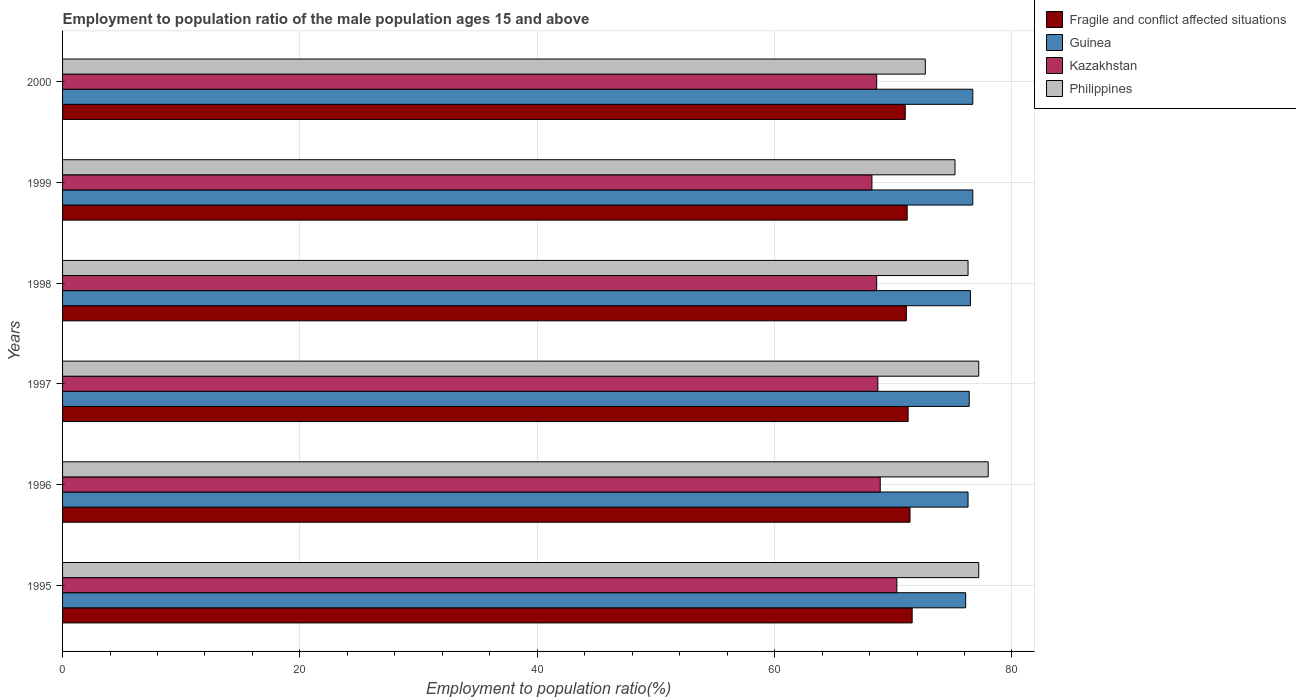How many different coloured bars are there?
Offer a terse response. 4. How many groups of bars are there?
Your response must be concise. 6. Are the number of bars on each tick of the Y-axis equal?
Keep it short and to the point. Yes. How many bars are there on the 5th tick from the bottom?
Provide a short and direct response. 4. What is the employment to population ratio in Guinea in 1997?
Provide a short and direct response. 76.4. Across all years, what is the maximum employment to population ratio in Kazakhstan?
Offer a terse response. 70.3. Across all years, what is the minimum employment to population ratio in Philippines?
Make the answer very short. 72.7. In which year was the employment to population ratio in Philippines maximum?
Your answer should be very brief. 1996. In which year was the employment to population ratio in Guinea minimum?
Offer a very short reply. 1995. What is the total employment to population ratio in Guinea in the graph?
Your answer should be compact. 458.7. What is the difference between the employment to population ratio in Fragile and conflict affected situations in 1998 and that in 2000?
Give a very brief answer. 0.09. What is the difference between the employment to population ratio in Kazakhstan in 1995 and the employment to population ratio in Guinea in 1997?
Your answer should be compact. -6.1. What is the average employment to population ratio in Kazakhstan per year?
Provide a short and direct response. 68.88. In the year 2000, what is the difference between the employment to population ratio in Kazakhstan and employment to population ratio in Fragile and conflict affected situations?
Give a very brief answer. -2.41. In how many years, is the employment to population ratio in Fragile and conflict affected situations greater than 4 %?
Offer a terse response. 6. What is the ratio of the employment to population ratio in Kazakhstan in 1997 to that in 1998?
Provide a short and direct response. 1. What is the difference between the highest and the second highest employment to population ratio in Kazakhstan?
Your answer should be compact. 1.4. What is the difference between the highest and the lowest employment to population ratio in Philippines?
Your answer should be very brief. 5.3. Is the sum of the employment to population ratio in Fragile and conflict affected situations in 1997 and 1998 greater than the maximum employment to population ratio in Guinea across all years?
Keep it short and to the point. Yes. What does the 3rd bar from the bottom in 2000 represents?
Ensure brevity in your answer.  Kazakhstan. Is it the case that in every year, the sum of the employment to population ratio in Guinea and employment to population ratio in Kazakhstan is greater than the employment to population ratio in Fragile and conflict affected situations?
Your response must be concise. Yes. How many years are there in the graph?
Provide a short and direct response. 6. What is the difference between two consecutive major ticks on the X-axis?
Ensure brevity in your answer.  20. Does the graph contain any zero values?
Your response must be concise. No. Does the graph contain grids?
Ensure brevity in your answer.  Yes. Where does the legend appear in the graph?
Offer a very short reply. Top right. How many legend labels are there?
Offer a very short reply. 4. What is the title of the graph?
Your response must be concise. Employment to population ratio of the male population ages 15 and above. What is the label or title of the X-axis?
Ensure brevity in your answer.  Employment to population ratio(%). What is the Employment to population ratio(%) of Fragile and conflict affected situations in 1995?
Offer a very short reply. 71.59. What is the Employment to population ratio(%) of Guinea in 1995?
Provide a succinct answer. 76.1. What is the Employment to population ratio(%) in Kazakhstan in 1995?
Your answer should be very brief. 70.3. What is the Employment to population ratio(%) in Philippines in 1995?
Ensure brevity in your answer.  77.2. What is the Employment to population ratio(%) of Fragile and conflict affected situations in 1996?
Make the answer very short. 71.41. What is the Employment to population ratio(%) in Guinea in 1996?
Offer a very short reply. 76.3. What is the Employment to population ratio(%) in Kazakhstan in 1996?
Make the answer very short. 68.9. What is the Employment to population ratio(%) in Fragile and conflict affected situations in 1997?
Your answer should be compact. 71.25. What is the Employment to population ratio(%) of Guinea in 1997?
Keep it short and to the point. 76.4. What is the Employment to population ratio(%) in Kazakhstan in 1997?
Make the answer very short. 68.7. What is the Employment to population ratio(%) in Philippines in 1997?
Provide a succinct answer. 77.2. What is the Employment to population ratio(%) of Fragile and conflict affected situations in 1998?
Your answer should be very brief. 71.1. What is the Employment to population ratio(%) in Guinea in 1998?
Ensure brevity in your answer.  76.5. What is the Employment to population ratio(%) of Kazakhstan in 1998?
Offer a terse response. 68.6. What is the Employment to population ratio(%) of Philippines in 1998?
Your answer should be very brief. 76.3. What is the Employment to population ratio(%) in Fragile and conflict affected situations in 1999?
Make the answer very short. 71.17. What is the Employment to population ratio(%) of Guinea in 1999?
Provide a succinct answer. 76.7. What is the Employment to population ratio(%) in Kazakhstan in 1999?
Give a very brief answer. 68.2. What is the Employment to population ratio(%) in Philippines in 1999?
Ensure brevity in your answer.  75.2. What is the Employment to population ratio(%) of Fragile and conflict affected situations in 2000?
Make the answer very short. 71.01. What is the Employment to population ratio(%) in Guinea in 2000?
Provide a short and direct response. 76.7. What is the Employment to population ratio(%) in Kazakhstan in 2000?
Ensure brevity in your answer.  68.6. What is the Employment to population ratio(%) in Philippines in 2000?
Offer a terse response. 72.7. Across all years, what is the maximum Employment to population ratio(%) in Fragile and conflict affected situations?
Offer a very short reply. 71.59. Across all years, what is the maximum Employment to population ratio(%) in Guinea?
Keep it short and to the point. 76.7. Across all years, what is the maximum Employment to population ratio(%) in Kazakhstan?
Keep it short and to the point. 70.3. Across all years, what is the maximum Employment to population ratio(%) in Philippines?
Offer a terse response. 78. Across all years, what is the minimum Employment to population ratio(%) of Fragile and conflict affected situations?
Provide a short and direct response. 71.01. Across all years, what is the minimum Employment to population ratio(%) in Guinea?
Keep it short and to the point. 76.1. Across all years, what is the minimum Employment to population ratio(%) in Kazakhstan?
Your answer should be compact. 68.2. Across all years, what is the minimum Employment to population ratio(%) of Philippines?
Provide a short and direct response. 72.7. What is the total Employment to population ratio(%) in Fragile and conflict affected situations in the graph?
Provide a short and direct response. 427.53. What is the total Employment to population ratio(%) of Guinea in the graph?
Offer a terse response. 458.7. What is the total Employment to population ratio(%) of Kazakhstan in the graph?
Make the answer very short. 413.3. What is the total Employment to population ratio(%) in Philippines in the graph?
Offer a terse response. 456.6. What is the difference between the Employment to population ratio(%) of Fragile and conflict affected situations in 1995 and that in 1996?
Give a very brief answer. 0.18. What is the difference between the Employment to population ratio(%) of Philippines in 1995 and that in 1996?
Provide a succinct answer. -0.8. What is the difference between the Employment to population ratio(%) in Fragile and conflict affected situations in 1995 and that in 1997?
Provide a short and direct response. 0.34. What is the difference between the Employment to population ratio(%) of Fragile and conflict affected situations in 1995 and that in 1998?
Give a very brief answer. 0.49. What is the difference between the Employment to population ratio(%) in Kazakhstan in 1995 and that in 1998?
Offer a terse response. 1.7. What is the difference between the Employment to population ratio(%) in Fragile and conflict affected situations in 1995 and that in 1999?
Provide a succinct answer. 0.42. What is the difference between the Employment to population ratio(%) in Philippines in 1995 and that in 1999?
Offer a terse response. 2. What is the difference between the Employment to population ratio(%) in Fragile and conflict affected situations in 1995 and that in 2000?
Provide a succinct answer. 0.58. What is the difference between the Employment to population ratio(%) in Kazakhstan in 1995 and that in 2000?
Your answer should be compact. 1.7. What is the difference between the Employment to population ratio(%) in Fragile and conflict affected situations in 1996 and that in 1997?
Provide a short and direct response. 0.16. What is the difference between the Employment to population ratio(%) of Guinea in 1996 and that in 1997?
Provide a short and direct response. -0.1. What is the difference between the Employment to population ratio(%) in Philippines in 1996 and that in 1997?
Your answer should be compact. 0.8. What is the difference between the Employment to population ratio(%) in Fragile and conflict affected situations in 1996 and that in 1998?
Provide a short and direct response. 0.31. What is the difference between the Employment to population ratio(%) in Fragile and conflict affected situations in 1996 and that in 1999?
Give a very brief answer. 0.24. What is the difference between the Employment to population ratio(%) of Philippines in 1996 and that in 1999?
Your response must be concise. 2.8. What is the difference between the Employment to population ratio(%) in Fragile and conflict affected situations in 1996 and that in 2000?
Your answer should be very brief. 0.4. What is the difference between the Employment to population ratio(%) in Kazakhstan in 1996 and that in 2000?
Your answer should be very brief. 0.3. What is the difference between the Employment to population ratio(%) of Fragile and conflict affected situations in 1997 and that in 1998?
Offer a very short reply. 0.15. What is the difference between the Employment to population ratio(%) of Kazakhstan in 1997 and that in 1998?
Keep it short and to the point. 0.1. What is the difference between the Employment to population ratio(%) in Philippines in 1997 and that in 1998?
Give a very brief answer. 0.9. What is the difference between the Employment to population ratio(%) in Fragile and conflict affected situations in 1997 and that in 1999?
Your response must be concise. 0.08. What is the difference between the Employment to population ratio(%) of Guinea in 1997 and that in 1999?
Keep it short and to the point. -0.3. What is the difference between the Employment to population ratio(%) of Philippines in 1997 and that in 1999?
Keep it short and to the point. 2. What is the difference between the Employment to population ratio(%) in Fragile and conflict affected situations in 1997 and that in 2000?
Your answer should be very brief. 0.24. What is the difference between the Employment to population ratio(%) in Philippines in 1997 and that in 2000?
Make the answer very short. 4.5. What is the difference between the Employment to population ratio(%) in Fragile and conflict affected situations in 1998 and that in 1999?
Offer a terse response. -0.07. What is the difference between the Employment to population ratio(%) in Guinea in 1998 and that in 1999?
Provide a succinct answer. -0.2. What is the difference between the Employment to population ratio(%) of Kazakhstan in 1998 and that in 1999?
Your answer should be compact. 0.4. What is the difference between the Employment to population ratio(%) in Philippines in 1998 and that in 1999?
Your response must be concise. 1.1. What is the difference between the Employment to population ratio(%) in Fragile and conflict affected situations in 1998 and that in 2000?
Ensure brevity in your answer.  0.09. What is the difference between the Employment to population ratio(%) in Philippines in 1998 and that in 2000?
Your answer should be very brief. 3.6. What is the difference between the Employment to population ratio(%) in Fragile and conflict affected situations in 1999 and that in 2000?
Your answer should be compact. 0.16. What is the difference between the Employment to population ratio(%) in Guinea in 1999 and that in 2000?
Your answer should be very brief. 0. What is the difference between the Employment to population ratio(%) in Fragile and conflict affected situations in 1995 and the Employment to population ratio(%) in Guinea in 1996?
Your answer should be very brief. -4.71. What is the difference between the Employment to population ratio(%) in Fragile and conflict affected situations in 1995 and the Employment to population ratio(%) in Kazakhstan in 1996?
Keep it short and to the point. 2.69. What is the difference between the Employment to population ratio(%) of Fragile and conflict affected situations in 1995 and the Employment to population ratio(%) of Philippines in 1996?
Keep it short and to the point. -6.41. What is the difference between the Employment to population ratio(%) in Kazakhstan in 1995 and the Employment to population ratio(%) in Philippines in 1996?
Your response must be concise. -7.7. What is the difference between the Employment to population ratio(%) in Fragile and conflict affected situations in 1995 and the Employment to population ratio(%) in Guinea in 1997?
Your response must be concise. -4.81. What is the difference between the Employment to population ratio(%) in Fragile and conflict affected situations in 1995 and the Employment to population ratio(%) in Kazakhstan in 1997?
Keep it short and to the point. 2.89. What is the difference between the Employment to population ratio(%) of Fragile and conflict affected situations in 1995 and the Employment to population ratio(%) of Philippines in 1997?
Make the answer very short. -5.61. What is the difference between the Employment to population ratio(%) in Guinea in 1995 and the Employment to population ratio(%) in Kazakhstan in 1997?
Make the answer very short. 7.4. What is the difference between the Employment to population ratio(%) of Guinea in 1995 and the Employment to population ratio(%) of Philippines in 1997?
Your response must be concise. -1.1. What is the difference between the Employment to population ratio(%) in Kazakhstan in 1995 and the Employment to population ratio(%) in Philippines in 1997?
Provide a succinct answer. -6.9. What is the difference between the Employment to population ratio(%) in Fragile and conflict affected situations in 1995 and the Employment to population ratio(%) in Guinea in 1998?
Your answer should be compact. -4.91. What is the difference between the Employment to population ratio(%) of Fragile and conflict affected situations in 1995 and the Employment to population ratio(%) of Kazakhstan in 1998?
Your answer should be very brief. 2.99. What is the difference between the Employment to population ratio(%) in Fragile and conflict affected situations in 1995 and the Employment to population ratio(%) in Philippines in 1998?
Provide a succinct answer. -4.71. What is the difference between the Employment to population ratio(%) in Guinea in 1995 and the Employment to population ratio(%) in Philippines in 1998?
Your answer should be very brief. -0.2. What is the difference between the Employment to population ratio(%) of Kazakhstan in 1995 and the Employment to population ratio(%) of Philippines in 1998?
Keep it short and to the point. -6. What is the difference between the Employment to population ratio(%) of Fragile and conflict affected situations in 1995 and the Employment to population ratio(%) of Guinea in 1999?
Offer a very short reply. -5.11. What is the difference between the Employment to population ratio(%) in Fragile and conflict affected situations in 1995 and the Employment to population ratio(%) in Kazakhstan in 1999?
Provide a short and direct response. 3.39. What is the difference between the Employment to population ratio(%) of Fragile and conflict affected situations in 1995 and the Employment to population ratio(%) of Philippines in 1999?
Your answer should be very brief. -3.61. What is the difference between the Employment to population ratio(%) of Guinea in 1995 and the Employment to population ratio(%) of Philippines in 1999?
Provide a succinct answer. 0.9. What is the difference between the Employment to population ratio(%) of Kazakhstan in 1995 and the Employment to population ratio(%) of Philippines in 1999?
Offer a very short reply. -4.9. What is the difference between the Employment to population ratio(%) in Fragile and conflict affected situations in 1995 and the Employment to population ratio(%) in Guinea in 2000?
Your answer should be compact. -5.11. What is the difference between the Employment to population ratio(%) in Fragile and conflict affected situations in 1995 and the Employment to population ratio(%) in Kazakhstan in 2000?
Your answer should be very brief. 2.99. What is the difference between the Employment to population ratio(%) in Fragile and conflict affected situations in 1995 and the Employment to population ratio(%) in Philippines in 2000?
Give a very brief answer. -1.11. What is the difference between the Employment to population ratio(%) of Guinea in 1995 and the Employment to population ratio(%) of Philippines in 2000?
Provide a short and direct response. 3.4. What is the difference between the Employment to population ratio(%) in Kazakhstan in 1995 and the Employment to population ratio(%) in Philippines in 2000?
Provide a succinct answer. -2.4. What is the difference between the Employment to population ratio(%) of Fragile and conflict affected situations in 1996 and the Employment to population ratio(%) of Guinea in 1997?
Give a very brief answer. -4.99. What is the difference between the Employment to population ratio(%) in Fragile and conflict affected situations in 1996 and the Employment to population ratio(%) in Kazakhstan in 1997?
Keep it short and to the point. 2.71. What is the difference between the Employment to population ratio(%) in Fragile and conflict affected situations in 1996 and the Employment to population ratio(%) in Philippines in 1997?
Your answer should be compact. -5.79. What is the difference between the Employment to population ratio(%) in Guinea in 1996 and the Employment to population ratio(%) in Kazakhstan in 1997?
Offer a very short reply. 7.6. What is the difference between the Employment to population ratio(%) of Kazakhstan in 1996 and the Employment to population ratio(%) of Philippines in 1997?
Offer a terse response. -8.3. What is the difference between the Employment to population ratio(%) in Fragile and conflict affected situations in 1996 and the Employment to population ratio(%) in Guinea in 1998?
Keep it short and to the point. -5.09. What is the difference between the Employment to population ratio(%) of Fragile and conflict affected situations in 1996 and the Employment to population ratio(%) of Kazakhstan in 1998?
Your answer should be compact. 2.81. What is the difference between the Employment to population ratio(%) in Fragile and conflict affected situations in 1996 and the Employment to population ratio(%) in Philippines in 1998?
Offer a terse response. -4.89. What is the difference between the Employment to population ratio(%) in Fragile and conflict affected situations in 1996 and the Employment to population ratio(%) in Guinea in 1999?
Provide a succinct answer. -5.29. What is the difference between the Employment to population ratio(%) in Fragile and conflict affected situations in 1996 and the Employment to population ratio(%) in Kazakhstan in 1999?
Offer a terse response. 3.21. What is the difference between the Employment to population ratio(%) in Fragile and conflict affected situations in 1996 and the Employment to population ratio(%) in Philippines in 1999?
Offer a terse response. -3.79. What is the difference between the Employment to population ratio(%) in Kazakhstan in 1996 and the Employment to population ratio(%) in Philippines in 1999?
Keep it short and to the point. -6.3. What is the difference between the Employment to population ratio(%) in Fragile and conflict affected situations in 1996 and the Employment to population ratio(%) in Guinea in 2000?
Give a very brief answer. -5.29. What is the difference between the Employment to population ratio(%) in Fragile and conflict affected situations in 1996 and the Employment to population ratio(%) in Kazakhstan in 2000?
Offer a very short reply. 2.81. What is the difference between the Employment to population ratio(%) of Fragile and conflict affected situations in 1996 and the Employment to population ratio(%) of Philippines in 2000?
Keep it short and to the point. -1.29. What is the difference between the Employment to population ratio(%) of Guinea in 1996 and the Employment to population ratio(%) of Philippines in 2000?
Your answer should be very brief. 3.6. What is the difference between the Employment to population ratio(%) in Kazakhstan in 1996 and the Employment to population ratio(%) in Philippines in 2000?
Make the answer very short. -3.8. What is the difference between the Employment to population ratio(%) in Fragile and conflict affected situations in 1997 and the Employment to population ratio(%) in Guinea in 1998?
Ensure brevity in your answer.  -5.25. What is the difference between the Employment to population ratio(%) of Fragile and conflict affected situations in 1997 and the Employment to population ratio(%) of Kazakhstan in 1998?
Your response must be concise. 2.65. What is the difference between the Employment to population ratio(%) of Fragile and conflict affected situations in 1997 and the Employment to population ratio(%) of Philippines in 1998?
Ensure brevity in your answer.  -5.05. What is the difference between the Employment to population ratio(%) of Guinea in 1997 and the Employment to population ratio(%) of Philippines in 1998?
Ensure brevity in your answer.  0.1. What is the difference between the Employment to population ratio(%) of Fragile and conflict affected situations in 1997 and the Employment to population ratio(%) of Guinea in 1999?
Keep it short and to the point. -5.45. What is the difference between the Employment to population ratio(%) of Fragile and conflict affected situations in 1997 and the Employment to population ratio(%) of Kazakhstan in 1999?
Make the answer very short. 3.05. What is the difference between the Employment to population ratio(%) in Fragile and conflict affected situations in 1997 and the Employment to population ratio(%) in Philippines in 1999?
Offer a terse response. -3.95. What is the difference between the Employment to population ratio(%) in Guinea in 1997 and the Employment to population ratio(%) in Kazakhstan in 1999?
Provide a succinct answer. 8.2. What is the difference between the Employment to population ratio(%) of Fragile and conflict affected situations in 1997 and the Employment to population ratio(%) of Guinea in 2000?
Give a very brief answer. -5.45. What is the difference between the Employment to population ratio(%) of Fragile and conflict affected situations in 1997 and the Employment to population ratio(%) of Kazakhstan in 2000?
Provide a short and direct response. 2.65. What is the difference between the Employment to population ratio(%) in Fragile and conflict affected situations in 1997 and the Employment to population ratio(%) in Philippines in 2000?
Ensure brevity in your answer.  -1.45. What is the difference between the Employment to population ratio(%) in Guinea in 1997 and the Employment to population ratio(%) in Philippines in 2000?
Ensure brevity in your answer.  3.7. What is the difference between the Employment to population ratio(%) in Fragile and conflict affected situations in 1998 and the Employment to population ratio(%) in Guinea in 1999?
Make the answer very short. -5.6. What is the difference between the Employment to population ratio(%) of Fragile and conflict affected situations in 1998 and the Employment to population ratio(%) of Kazakhstan in 1999?
Make the answer very short. 2.9. What is the difference between the Employment to population ratio(%) of Fragile and conflict affected situations in 1998 and the Employment to population ratio(%) of Philippines in 1999?
Offer a very short reply. -4.1. What is the difference between the Employment to population ratio(%) in Fragile and conflict affected situations in 1998 and the Employment to population ratio(%) in Guinea in 2000?
Make the answer very short. -5.6. What is the difference between the Employment to population ratio(%) in Fragile and conflict affected situations in 1998 and the Employment to population ratio(%) in Kazakhstan in 2000?
Offer a terse response. 2.5. What is the difference between the Employment to population ratio(%) in Fragile and conflict affected situations in 1998 and the Employment to population ratio(%) in Philippines in 2000?
Your answer should be very brief. -1.6. What is the difference between the Employment to population ratio(%) of Guinea in 1998 and the Employment to population ratio(%) of Kazakhstan in 2000?
Your answer should be compact. 7.9. What is the difference between the Employment to population ratio(%) in Kazakhstan in 1998 and the Employment to population ratio(%) in Philippines in 2000?
Provide a succinct answer. -4.1. What is the difference between the Employment to population ratio(%) of Fragile and conflict affected situations in 1999 and the Employment to population ratio(%) of Guinea in 2000?
Offer a terse response. -5.53. What is the difference between the Employment to population ratio(%) of Fragile and conflict affected situations in 1999 and the Employment to population ratio(%) of Kazakhstan in 2000?
Offer a terse response. 2.57. What is the difference between the Employment to population ratio(%) of Fragile and conflict affected situations in 1999 and the Employment to population ratio(%) of Philippines in 2000?
Give a very brief answer. -1.53. What is the difference between the Employment to population ratio(%) in Kazakhstan in 1999 and the Employment to population ratio(%) in Philippines in 2000?
Your answer should be compact. -4.5. What is the average Employment to population ratio(%) of Fragile and conflict affected situations per year?
Keep it short and to the point. 71.26. What is the average Employment to population ratio(%) in Guinea per year?
Provide a short and direct response. 76.45. What is the average Employment to population ratio(%) in Kazakhstan per year?
Offer a very short reply. 68.88. What is the average Employment to population ratio(%) of Philippines per year?
Your answer should be compact. 76.1. In the year 1995, what is the difference between the Employment to population ratio(%) of Fragile and conflict affected situations and Employment to population ratio(%) of Guinea?
Ensure brevity in your answer.  -4.51. In the year 1995, what is the difference between the Employment to population ratio(%) in Fragile and conflict affected situations and Employment to population ratio(%) in Kazakhstan?
Provide a short and direct response. 1.29. In the year 1995, what is the difference between the Employment to population ratio(%) of Fragile and conflict affected situations and Employment to population ratio(%) of Philippines?
Make the answer very short. -5.61. In the year 1995, what is the difference between the Employment to population ratio(%) of Guinea and Employment to population ratio(%) of Kazakhstan?
Provide a short and direct response. 5.8. In the year 1995, what is the difference between the Employment to population ratio(%) in Guinea and Employment to population ratio(%) in Philippines?
Your response must be concise. -1.1. In the year 1995, what is the difference between the Employment to population ratio(%) in Kazakhstan and Employment to population ratio(%) in Philippines?
Your response must be concise. -6.9. In the year 1996, what is the difference between the Employment to population ratio(%) in Fragile and conflict affected situations and Employment to population ratio(%) in Guinea?
Ensure brevity in your answer.  -4.89. In the year 1996, what is the difference between the Employment to population ratio(%) of Fragile and conflict affected situations and Employment to population ratio(%) of Kazakhstan?
Give a very brief answer. 2.51. In the year 1996, what is the difference between the Employment to population ratio(%) of Fragile and conflict affected situations and Employment to population ratio(%) of Philippines?
Ensure brevity in your answer.  -6.59. In the year 1996, what is the difference between the Employment to population ratio(%) in Guinea and Employment to population ratio(%) in Kazakhstan?
Offer a terse response. 7.4. In the year 1996, what is the difference between the Employment to population ratio(%) of Kazakhstan and Employment to population ratio(%) of Philippines?
Your response must be concise. -9.1. In the year 1997, what is the difference between the Employment to population ratio(%) of Fragile and conflict affected situations and Employment to population ratio(%) of Guinea?
Offer a terse response. -5.15. In the year 1997, what is the difference between the Employment to population ratio(%) of Fragile and conflict affected situations and Employment to population ratio(%) of Kazakhstan?
Provide a short and direct response. 2.55. In the year 1997, what is the difference between the Employment to population ratio(%) of Fragile and conflict affected situations and Employment to population ratio(%) of Philippines?
Give a very brief answer. -5.95. In the year 1997, what is the difference between the Employment to population ratio(%) in Guinea and Employment to population ratio(%) in Kazakhstan?
Give a very brief answer. 7.7. In the year 1997, what is the difference between the Employment to population ratio(%) of Kazakhstan and Employment to population ratio(%) of Philippines?
Give a very brief answer. -8.5. In the year 1998, what is the difference between the Employment to population ratio(%) in Fragile and conflict affected situations and Employment to population ratio(%) in Guinea?
Offer a terse response. -5.4. In the year 1998, what is the difference between the Employment to population ratio(%) of Fragile and conflict affected situations and Employment to population ratio(%) of Kazakhstan?
Make the answer very short. 2.5. In the year 1998, what is the difference between the Employment to population ratio(%) in Fragile and conflict affected situations and Employment to population ratio(%) in Philippines?
Your answer should be very brief. -5.2. In the year 1998, what is the difference between the Employment to population ratio(%) in Guinea and Employment to population ratio(%) in Philippines?
Keep it short and to the point. 0.2. In the year 1998, what is the difference between the Employment to population ratio(%) of Kazakhstan and Employment to population ratio(%) of Philippines?
Provide a short and direct response. -7.7. In the year 1999, what is the difference between the Employment to population ratio(%) of Fragile and conflict affected situations and Employment to population ratio(%) of Guinea?
Give a very brief answer. -5.53. In the year 1999, what is the difference between the Employment to population ratio(%) in Fragile and conflict affected situations and Employment to population ratio(%) in Kazakhstan?
Offer a terse response. 2.97. In the year 1999, what is the difference between the Employment to population ratio(%) in Fragile and conflict affected situations and Employment to population ratio(%) in Philippines?
Provide a succinct answer. -4.03. In the year 1999, what is the difference between the Employment to population ratio(%) of Guinea and Employment to population ratio(%) of Kazakhstan?
Offer a terse response. 8.5. In the year 1999, what is the difference between the Employment to population ratio(%) in Guinea and Employment to population ratio(%) in Philippines?
Offer a very short reply. 1.5. In the year 1999, what is the difference between the Employment to population ratio(%) of Kazakhstan and Employment to population ratio(%) of Philippines?
Provide a short and direct response. -7. In the year 2000, what is the difference between the Employment to population ratio(%) in Fragile and conflict affected situations and Employment to population ratio(%) in Guinea?
Offer a very short reply. -5.69. In the year 2000, what is the difference between the Employment to population ratio(%) in Fragile and conflict affected situations and Employment to population ratio(%) in Kazakhstan?
Keep it short and to the point. 2.41. In the year 2000, what is the difference between the Employment to population ratio(%) of Fragile and conflict affected situations and Employment to population ratio(%) of Philippines?
Ensure brevity in your answer.  -1.69. What is the ratio of the Employment to population ratio(%) in Fragile and conflict affected situations in 1995 to that in 1996?
Ensure brevity in your answer.  1. What is the ratio of the Employment to population ratio(%) of Guinea in 1995 to that in 1996?
Offer a very short reply. 1. What is the ratio of the Employment to population ratio(%) of Kazakhstan in 1995 to that in 1996?
Offer a very short reply. 1.02. What is the ratio of the Employment to population ratio(%) in Kazakhstan in 1995 to that in 1997?
Ensure brevity in your answer.  1.02. What is the ratio of the Employment to population ratio(%) of Philippines in 1995 to that in 1997?
Your response must be concise. 1. What is the ratio of the Employment to population ratio(%) of Guinea in 1995 to that in 1998?
Provide a succinct answer. 0.99. What is the ratio of the Employment to population ratio(%) of Kazakhstan in 1995 to that in 1998?
Offer a very short reply. 1.02. What is the ratio of the Employment to population ratio(%) in Philippines in 1995 to that in 1998?
Your response must be concise. 1.01. What is the ratio of the Employment to population ratio(%) of Fragile and conflict affected situations in 1995 to that in 1999?
Provide a short and direct response. 1.01. What is the ratio of the Employment to population ratio(%) of Guinea in 1995 to that in 1999?
Offer a very short reply. 0.99. What is the ratio of the Employment to population ratio(%) of Kazakhstan in 1995 to that in 1999?
Your response must be concise. 1.03. What is the ratio of the Employment to population ratio(%) of Philippines in 1995 to that in 1999?
Your answer should be very brief. 1.03. What is the ratio of the Employment to population ratio(%) in Fragile and conflict affected situations in 1995 to that in 2000?
Provide a succinct answer. 1.01. What is the ratio of the Employment to population ratio(%) in Kazakhstan in 1995 to that in 2000?
Your answer should be compact. 1.02. What is the ratio of the Employment to population ratio(%) in Philippines in 1995 to that in 2000?
Your response must be concise. 1.06. What is the ratio of the Employment to population ratio(%) in Fragile and conflict affected situations in 1996 to that in 1997?
Offer a very short reply. 1. What is the ratio of the Employment to population ratio(%) in Kazakhstan in 1996 to that in 1997?
Offer a terse response. 1. What is the ratio of the Employment to population ratio(%) of Philippines in 1996 to that in 1997?
Provide a short and direct response. 1.01. What is the ratio of the Employment to population ratio(%) of Fragile and conflict affected situations in 1996 to that in 1998?
Make the answer very short. 1. What is the ratio of the Employment to population ratio(%) of Guinea in 1996 to that in 1998?
Ensure brevity in your answer.  1. What is the ratio of the Employment to population ratio(%) in Philippines in 1996 to that in 1998?
Give a very brief answer. 1.02. What is the ratio of the Employment to population ratio(%) in Fragile and conflict affected situations in 1996 to that in 1999?
Provide a short and direct response. 1. What is the ratio of the Employment to population ratio(%) of Guinea in 1996 to that in 1999?
Your answer should be very brief. 0.99. What is the ratio of the Employment to population ratio(%) in Kazakhstan in 1996 to that in 1999?
Your answer should be very brief. 1.01. What is the ratio of the Employment to population ratio(%) in Philippines in 1996 to that in 1999?
Offer a very short reply. 1.04. What is the ratio of the Employment to population ratio(%) in Fragile and conflict affected situations in 1996 to that in 2000?
Provide a succinct answer. 1.01. What is the ratio of the Employment to population ratio(%) in Guinea in 1996 to that in 2000?
Your response must be concise. 0.99. What is the ratio of the Employment to population ratio(%) in Kazakhstan in 1996 to that in 2000?
Your answer should be compact. 1. What is the ratio of the Employment to population ratio(%) in Philippines in 1996 to that in 2000?
Provide a succinct answer. 1.07. What is the ratio of the Employment to population ratio(%) of Philippines in 1997 to that in 1998?
Your response must be concise. 1.01. What is the ratio of the Employment to population ratio(%) in Kazakhstan in 1997 to that in 1999?
Offer a very short reply. 1.01. What is the ratio of the Employment to population ratio(%) of Philippines in 1997 to that in 1999?
Your answer should be very brief. 1.03. What is the ratio of the Employment to population ratio(%) in Guinea in 1997 to that in 2000?
Offer a very short reply. 1. What is the ratio of the Employment to population ratio(%) of Kazakhstan in 1997 to that in 2000?
Offer a terse response. 1. What is the ratio of the Employment to population ratio(%) in Philippines in 1997 to that in 2000?
Provide a short and direct response. 1.06. What is the ratio of the Employment to population ratio(%) of Guinea in 1998 to that in 1999?
Ensure brevity in your answer.  1. What is the ratio of the Employment to population ratio(%) in Kazakhstan in 1998 to that in 1999?
Give a very brief answer. 1.01. What is the ratio of the Employment to population ratio(%) of Philippines in 1998 to that in 1999?
Provide a short and direct response. 1.01. What is the ratio of the Employment to population ratio(%) of Kazakhstan in 1998 to that in 2000?
Make the answer very short. 1. What is the ratio of the Employment to population ratio(%) of Philippines in 1998 to that in 2000?
Your response must be concise. 1.05. What is the ratio of the Employment to population ratio(%) of Kazakhstan in 1999 to that in 2000?
Your response must be concise. 0.99. What is the ratio of the Employment to population ratio(%) in Philippines in 1999 to that in 2000?
Your response must be concise. 1.03. What is the difference between the highest and the second highest Employment to population ratio(%) in Fragile and conflict affected situations?
Provide a succinct answer. 0.18. What is the difference between the highest and the second highest Employment to population ratio(%) in Kazakhstan?
Your response must be concise. 1.4. What is the difference between the highest and the lowest Employment to population ratio(%) in Fragile and conflict affected situations?
Offer a very short reply. 0.58. What is the difference between the highest and the lowest Employment to population ratio(%) in Kazakhstan?
Ensure brevity in your answer.  2.1. What is the difference between the highest and the lowest Employment to population ratio(%) in Philippines?
Keep it short and to the point. 5.3. 